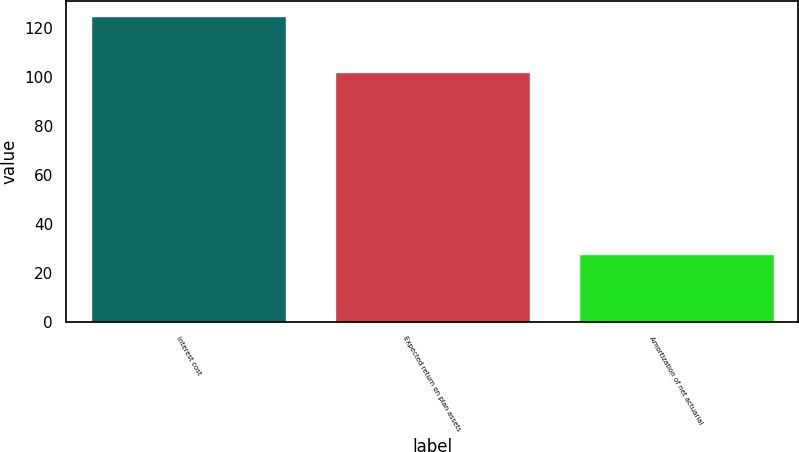Convert chart to OTSL. <chart><loc_0><loc_0><loc_500><loc_500><bar_chart><fcel>Interest cost<fcel>Expected return on plan assets<fcel>Amortization of net actuarial<nl><fcel>125<fcel>102<fcel>28<nl></chart> 